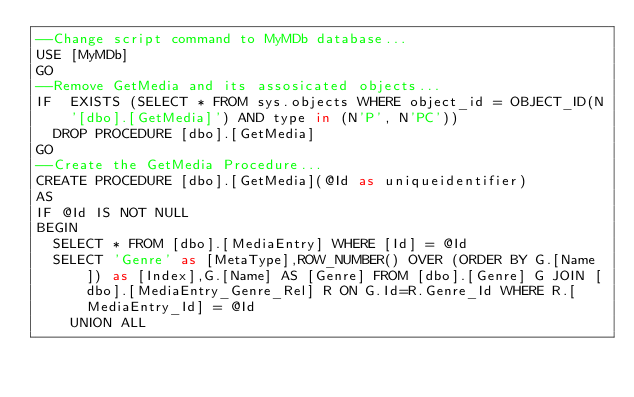Convert code to text. <code><loc_0><loc_0><loc_500><loc_500><_SQL_>--Change script command to MyMDb database...
USE [MyMDb]
GO
--Remove GetMedia and its assosicated objects...
IF  EXISTS (SELECT * FROM sys.objects WHERE object_id = OBJECT_ID(N'[dbo].[GetMedia]') AND type in (N'P', N'PC'))
	DROP PROCEDURE [dbo].[GetMedia]
GO
--Create the GetMedia Procedure...
CREATE PROCEDURE [dbo].[GetMedia](@Id as uniqueidentifier)
AS
IF @Id IS NOT NULL
BEGIN
	SELECT * FROM [dbo].[MediaEntry] WHERE [Id] = @Id
	SELECT 'Genre' as [MetaType],ROW_NUMBER() OVER (ORDER BY G.[Name]) as [Index],G.[Name] AS [Genre] FROM [dbo].[Genre] G JOIN [dbo].[MediaEntry_Genre_Rel] R ON G.Id=R.Genre_Id WHERE R.[MediaEntry_Id] = @Id
		UNION ALL</code> 